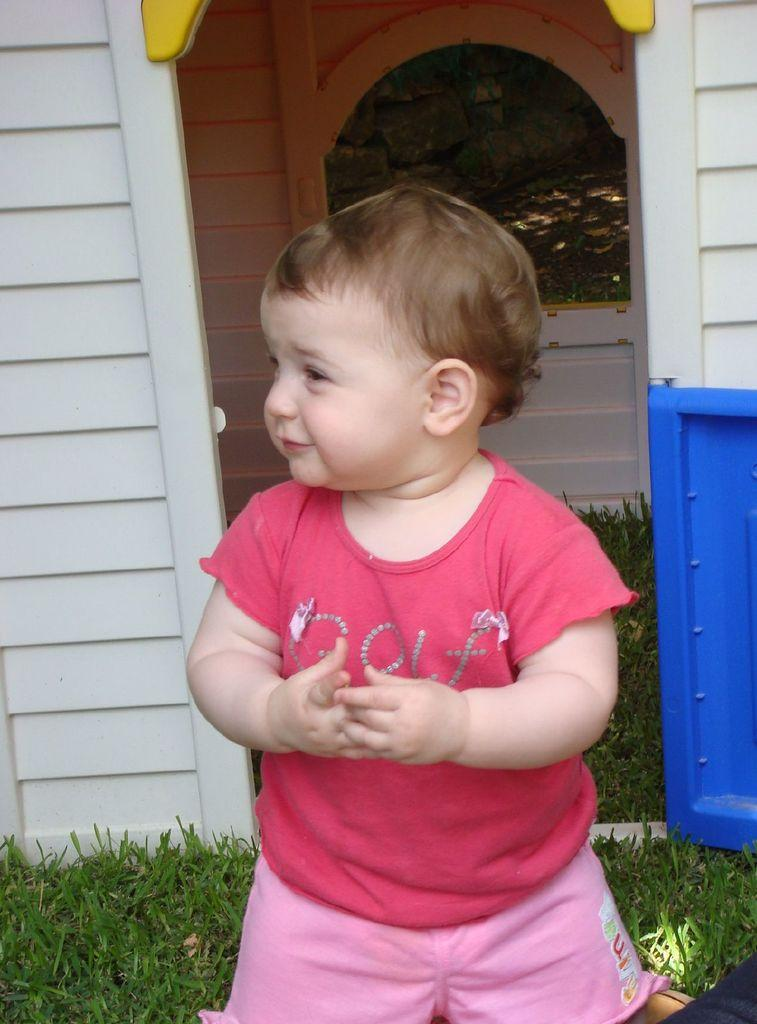What is the main subject of the image? There is a small boy standing in the image. What type of setting is depicted in the image? The image appears to be of a playhouse. What type of ground is visible in the image? There is grass visible in the image. What color is the door in the image? There is a blue door in the image. What type of riddle can be seen written on the wall of the playhouse in the image? There is no riddle visible on the wall of the playhouse in the image. 